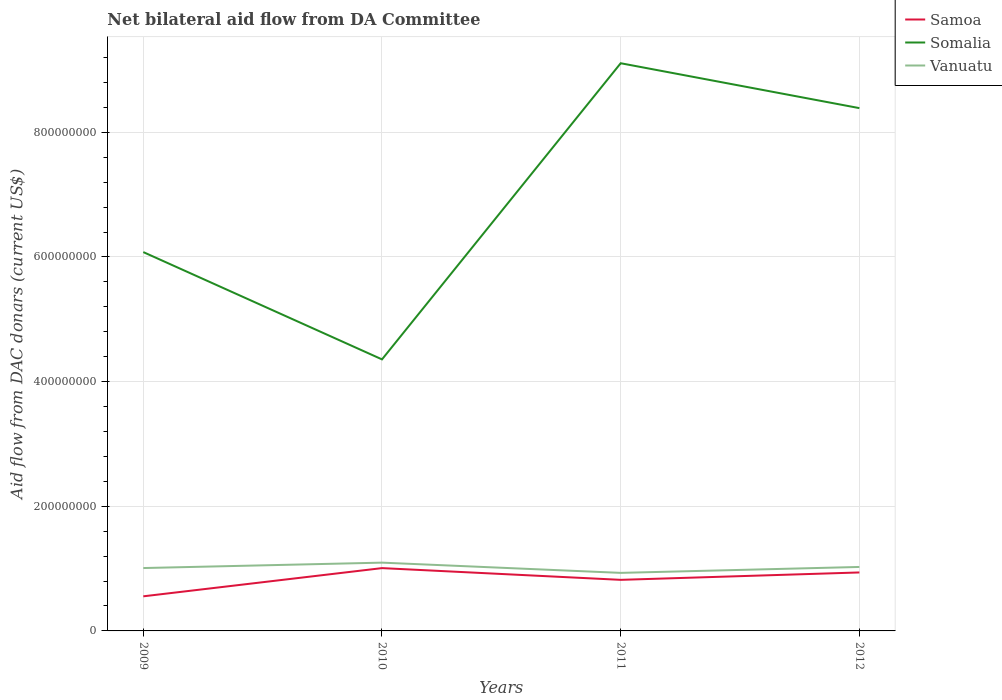Does the line corresponding to Vanuatu intersect with the line corresponding to Samoa?
Offer a very short reply. No. Across all years, what is the maximum aid flow in in Somalia?
Give a very brief answer. 4.36e+08. In which year was the aid flow in in Somalia maximum?
Provide a short and direct response. 2010. What is the total aid flow in in Samoa in the graph?
Your answer should be compact. -4.53e+07. What is the difference between the highest and the second highest aid flow in in Somalia?
Ensure brevity in your answer.  4.75e+08. How many lines are there?
Your response must be concise. 3. Where does the legend appear in the graph?
Offer a very short reply. Top right. How many legend labels are there?
Provide a succinct answer. 3. How are the legend labels stacked?
Offer a terse response. Vertical. What is the title of the graph?
Keep it short and to the point. Net bilateral aid flow from DA Committee. Does "Honduras" appear as one of the legend labels in the graph?
Offer a terse response. No. What is the label or title of the X-axis?
Give a very brief answer. Years. What is the label or title of the Y-axis?
Keep it short and to the point. Aid flow from DAC donars (current US$). What is the Aid flow from DAC donars (current US$) of Samoa in 2009?
Provide a short and direct response. 5.55e+07. What is the Aid flow from DAC donars (current US$) of Somalia in 2009?
Your answer should be very brief. 6.08e+08. What is the Aid flow from DAC donars (current US$) in Vanuatu in 2009?
Your answer should be very brief. 1.01e+08. What is the Aid flow from DAC donars (current US$) in Samoa in 2010?
Provide a short and direct response. 1.01e+08. What is the Aid flow from DAC donars (current US$) in Somalia in 2010?
Make the answer very short. 4.36e+08. What is the Aid flow from DAC donars (current US$) in Vanuatu in 2010?
Make the answer very short. 1.10e+08. What is the Aid flow from DAC donars (current US$) of Samoa in 2011?
Give a very brief answer. 8.19e+07. What is the Aid flow from DAC donars (current US$) of Somalia in 2011?
Ensure brevity in your answer.  9.11e+08. What is the Aid flow from DAC donars (current US$) in Vanuatu in 2011?
Your answer should be compact. 9.31e+07. What is the Aid flow from DAC donars (current US$) of Samoa in 2012?
Ensure brevity in your answer.  9.38e+07. What is the Aid flow from DAC donars (current US$) of Somalia in 2012?
Your response must be concise. 8.39e+08. What is the Aid flow from DAC donars (current US$) of Vanuatu in 2012?
Ensure brevity in your answer.  1.03e+08. Across all years, what is the maximum Aid flow from DAC donars (current US$) of Samoa?
Offer a terse response. 1.01e+08. Across all years, what is the maximum Aid flow from DAC donars (current US$) of Somalia?
Make the answer very short. 9.11e+08. Across all years, what is the maximum Aid flow from DAC donars (current US$) of Vanuatu?
Keep it short and to the point. 1.10e+08. Across all years, what is the minimum Aid flow from DAC donars (current US$) in Samoa?
Your answer should be very brief. 5.55e+07. Across all years, what is the minimum Aid flow from DAC donars (current US$) in Somalia?
Ensure brevity in your answer.  4.36e+08. Across all years, what is the minimum Aid flow from DAC donars (current US$) in Vanuatu?
Your response must be concise. 9.31e+07. What is the total Aid flow from DAC donars (current US$) in Samoa in the graph?
Ensure brevity in your answer.  3.32e+08. What is the total Aid flow from DAC donars (current US$) of Somalia in the graph?
Offer a very short reply. 2.79e+09. What is the total Aid flow from DAC donars (current US$) in Vanuatu in the graph?
Provide a short and direct response. 4.06e+08. What is the difference between the Aid flow from DAC donars (current US$) in Samoa in 2009 and that in 2010?
Provide a succinct answer. -4.53e+07. What is the difference between the Aid flow from DAC donars (current US$) in Somalia in 2009 and that in 2010?
Provide a short and direct response. 1.72e+08. What is the difference between the Aid flow from DAC donars (current US$) in Vanuatu in 2009 and that in 2010?
Give a very brief answer. -8.69e+06. What is the difference between the Aid flow from DAC donars (current US$) of Samoa in 2009 and that in 2011?
Provide a succinct answer. -2.64e+07. What is the difference between the Aid flow from DAC donars (current US$) in Somalia in 2009 and that in 2011?
Keep it short and to the point. -3.03e+08. What is the difference between the Aid flow from DAC donars (current US$) in Vanuatu in 2009 and that in 2011?
Ensure brevity in your answer.  7.74e+06. What is the difference between the Aid flow from DAC donars (current US$) in Samoa in 2009 and that in 2012?
Provide a short and direct response. -3.83e+07. What is the difference between the Aid flow from DAC donars (current US$) in Somalia in 2009 and that in 2012?
Keep it short and to the point. -2.31e+08. What is the difference between the Aid flow from DAC donars (current US$) of Vanuatu in 2009 and that in 2012?
Offer a terse response. -1.76e+06. What is the difference between the Aid flow from DAC donars (current US$) in Samoa in 2010 and that in 2011?
Provide a succinct answer. 1.88e+07. What is the difference between the Aid flow from DAC donars (current US$) in Somalia in 2010 and that in 2011?
Provide a succinct answer. -4.75e+08. What is the difference between the Aid flow from DAC donars (current US$) of Vanuatu in 2010 and that in 2011?
Make the answer very short. 1.64e+07. What is the difference between the Aid flow from DAC donars (current US$) in Samoa in 2010 and that in 2012?
Offer a terse response. 6.96e+06. What is the difference between the Aid flow from DAC donars (current US$) in Somalia in 2010 and that in 2012?
Ensure brevity in your answer.  -4.03e+08. What is the difference between the Aid flow from DAC donars (current US$) in Vanuatu in 2010 and that in 2012?
Provide a succinct answer. 6.93e+06. What is the difference between the Aid flow from DAC donars (current US$) in Samoa in 2011 and that in 2012?
Keep it short and to the point. -1.19e+07. What is the difference between the Aid flow from DAC donars (current US$) in Somalia in 2011 and that in 2012?
Your answer should be very brief. 7.20e+07. What is the difference between the Aid flow from DAC donars (current US$) of Vanuatu in 2011 and that in 2012?
Offer a very short reply. -9.50e+06. What is the difference between the Aid flow from DAC donars (current US$) in Samoa in 2009 and the Aid flow from DAC donars (current US$) in Somalia in 2010?
Provide a short and direct response. -3.80e+08. What is the difference between the Aid flow from DAC donars (current US$) of Samoa in 2009 and the Aid flow from DAC donars (current US$) of Vanuatu in 2010?
Ensure brevity in your answer.  -5.40e+07. What is the difference between the Aid flow from DAC donars (current US$) in Somalia in 2009 and the Aid flow from DAC donars (current US$) in Vanuatu in 2010?
Offer a terse response. 4.98e+08. What is the difference between the Aid flow from DAC donars (current US$) of Samoa in 2009 and the Aid flow from DAC donars (current US$) of Somalia in 2011?
Provide a succinct answer. -8.55e+08. What is the difference between the Aid flow from DAC donars (current US$) in Samoa in 2009 and the Aid flow from DAC donars (current US$) in Vanuatu in 2011?
Offer a terse response. -3.76e+07. What is the difference between the Aid flow from DAC donars (current US$) in Somalia in 2009 and the Aid flow from DAC donars (current US$) in Vanuatu in 2011?
Keep it short and to the point. 5.15e+08. What is the difference between the Aid flow from DAC donars (current US$) of Samoa in 2009 and the Aid flow from DAC donars (current US$) of Somalia in 2012?
Offer a very short reply. -7.83e+08. What is the difference between the Aid flow from DAC donars (current US$) in Samoa in 2009 and the Aid flow from DAC donars (current US$) in Vanuatu in 2012?
Your answer should be very brief. -4.71e+07. What is the difference between the Aid flow from DAC donars (current US$) of Somalia in 2009 and the Aid flow from DAC donars (current US$) of Vanuatu in 2012?
Your answer should be very brief. 5.05e+08. What is the difference between the Aid flow from DAC donars (current US$) of Samoa in 2010 and the Aid flow from DAC donars (current US$) of Somalia in 2011?
Ensure brevity in your answer.  -8.10e+08. What is the difference between the Aid flow from DAC donars (current US$) of Samoa in 2010 and the Aid flow from DAC donars (current US$) of Vanuatu in 2011?
Provide a succinct answer. 7.64e+06. What is the difference between the Aid flow from DAC donars (current US$) of Somalia in 2010 and the Aid flow from DAC donars (current US$) of Vanuatu in 2011?
Give a very brief answer. 3.43e+08. What is the difference between the Aid flow from DAC donars (current US$) of Samoa in 2010 and the Aid flow from DAC donars (current US$) of Somalia in 2012?
Provide a succinct answer. -7.38e+08. What is the difference between the Aid flow from DAC donars (current US$) in Samoa in 2010 and the Aid flow from DAC donars (current US$) in Vanuatu in 2012?
Your answer should be compact. -1.86e+06. What is the difference between the Aid flow from DAC donars (current US$) of Somalia in 2010 and the Aid flow from DAC donars (current US$) of Vanuatu in 2012?
Provide a succinct answer. 3.33e+08. What is the difference between the Aid flow from DAC donars (current US$) of Samoa in 2011 and the Aid flow from DAC donars (current US$) of Somalia in 2012?
Provide a short and direct response. -7.57e+08. What is the difference between the Aid flow from DAC donars (current US$) of Samoa in 2011 and the Aid flow from DAC donars (current US$) of Vanuatu in 2012?
Offer a terse response. -2.07e+07. What is the difference between the Aid flow from DAC donars (current US$) of Somalia in 2011 and the Aid flow from DAC donars (current US$) of Vanuatu in 2012?
Your answer should be very brief. 8.08e+08. What is the average Aid flow from DAC donars (current US$) of Samoa per year?
Your answer should be compact. 8.30e+07. What is the average Aid flow from DAC donars (current US$) in Somalia per year?
Ensure brevity in your answer.  6.98e+08. What is the average Aid flow from DAC donars (current US$) of Vanuatu per year?
Offer a terse response. 1.02e+08. In the year 2009, what is the difference between the Aid flow from DAC donars (current US$) of Samoa and Aid flow from DAC donars (current US$) of Somalia?
Your answer should be very brief. -5.52e+08. In the year 2009, what is the difference between the Aid flow from DAC donars (current US$) of Samoa and Aid flow from DAC donars (current US$) of Vanuatu?
Your answer should be compact. -4.54e+07. In the year 2009, what is the difference between the Aid flow from DAC donars (current US$) in Somalia and Aid flow from DAC donars (current US$) in Vanuatu?
Provide a succinct answer. 5.07e+08. In the year 2010, what is the difference between the Aid flow from DAC donars (current US$) in Samoa and Aid flow from DAC donars (current US$) in Somalia?
Keep it short and to the point. -3.35e+08. In the year 2010, what is the difference between the Aid flow from DAC donars (current US$) of Samoa and Aid flow from DAC donars (current US$) of Vanuatu?
Keep it short and to the point. -8.79e+06. In the year 2010, what is the difference between the Aid flow from DAC donars (current US$) in Somalia and Aid flow from DAC donars (current US$) in Vanuatu?
Keep it short and to the point. 3.26e+08. In the year 2011, what is the difference between the Aid flow from DAC donars (current US$) of Samoa and Aid flow from DAC donars (current US$) of Somalia?
Give a very brief answer. -8.29e+08. In the year 2011, what is the difference between the Aid flow from DAC donars (current US$) in Samoa and Aid flow from DAC donars (current US$) in Vanuatu?
Your response must be concise. -1.12e+07. In the year 2011, what is the difference between the Aid flow from DAC donars (current US$) of Somalia and Aid flow from DAC donars (current US$) of Vanuatu?
Your answer should be very brief. 8.18e+08. In the year 2012, what is the difference between the Aid flow from DAC donars (current US$) of Samoa and Aid flow from DAC donars (current US$) of Somalia?
Give a very brief answer. -7.45e+08. In the year 2012, what is the difference between the Aid flow from DAC donars (current US$) of Samoa and Aid flow from DAC donars (current US$) of Vanuatu?
Your answer should be very brief. -8.82e+06. In the year 2012, what is the difference between the Aid flow from DAC donars (current US$) of Somalia and Aid flow from DAC donars (current US$) of Vanuatu?
Offer a terse response. 7.36e+08. What is the ratio of the Aid flow from DAC donars (current US$) of Samoa in 2009 to that in 2010?
Your answer should be very brief. 0.55. What is the ratio of the Aid flow from DAC donars (current US$) of Somalia in 2009 to that in 2010?
Your answer should be compact. 1.4. What is the ratio of the Aid flow from DAC donars (current US$) in Vanuatu in 2009 to that in 2010?
Your answer should be compact. 0.92. What is the ratio of the Aid flow from DAC donars (current US$) of Samoa in 2009 to that in 2011?
Give a very brief answer. 0.68. What is the ratio of the Aid flow from DAC donars (current US$) in Somalia in 2009 to that in 2011?
Your answer should be very brief. 0.67. What is the ratio of the Aid flow from DAC donars (current US$) in Vanuatu in 2009 to that in 2011?
Your answer should be compact. 1.08. What is the ratio of the Aid flow from DAC donars (current US$) of Samoa in 2009 to that in 2012?
Make the answer very short. 0.59. What is the ratio of the Aid flow from DAC donars (current US$) in Somalia in 2009 to that in 2012?
Make the answer very short. 0.72. What is the ratio of the Aid flow from DAC donars (current US$) of Vanuatu in 2009 to that in 2012?
Your response must be concise. 0.98. What is the ratio of the Aid flow from DAC donars (current US$) of Samoa in 2010 to that in 2011?
Offer a very short reply. 1.23. What is the ratio of the Aid flow from DAC donars (current US$) in Somalia in 2010 to that in 2011?
Provide a succinct answer. 0.48. What is the ratio of the Aid flow from DAC donars (current US$) of Vanuatu in 2010 to that in 2011?
Keep it short and to the point. 1.18. What is the ratio of the Aid flow from DAC donars (current US$) of Samoa in 2010 to that in 2012?
Provide a short and direct response. 1.07. What is the ratio of the Aid flow from DAC donars (current US$) in Somalia in 2010 to that in 2012?
Offer a very short reply. 0.52. What is the ratio of the Aid flow from DAC donars (current US$) of Vanuatu in 2010 to that in 2012?
Offer a very short reply. 1.07. What is the ratio of the Aid flow from DAC donars (current US$) of Samoa in 2011 to that in 2012?
Make the answer very short. 0.87. What is the ratio of the Aid flow from DAC donars (current US$) in Somalia in 2011 to that in 2012?
Ensure brevity in your answer.  1.09. What is the ratio of the Aid flow from DAC donars (current US$) in Vanuatu in 2011 to that in 2012?
Ensure brevity in your answer.  0.91. What is the difference between the highest and the second highest Aid flow from DAC donars (current US$) of Samoa?
Provide a succinct answer. 6.96e+06. What is the difference between the highest and the second highest Aid flow from DAC donars (current US$) of Somalia?
Your answer should be compact. 7.20e+07. What is the difference between the highest and the second highest Aid flow from DAC donars (current US$) in Vanuatu?
Your answer should be very brief. 6.93e+06. What is the difference between the highest and the lowest Aid flow from DAC donars (current US$) in Samoa?
Give a very brief answer. 4.53e+07. What is the difference between the highest and the lowest Aid flow from DAC donars (current US$) of Somalia?
Provide a short and direct response. 4.75e+08. What is the difference between the highest and the lowest Aid flow from DAC donars (current US$) in Vanuatu?
Offer a terse response. 1.64e+07. 